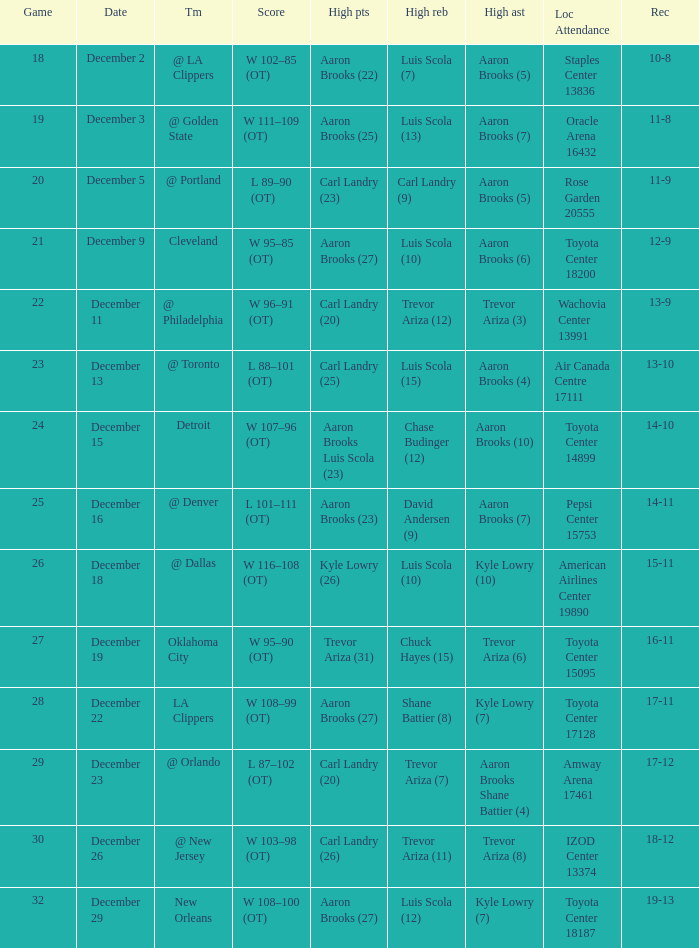Who did the high rebounds in the game where Carl Landry (23) did the most high points? Carl Landry (9). 